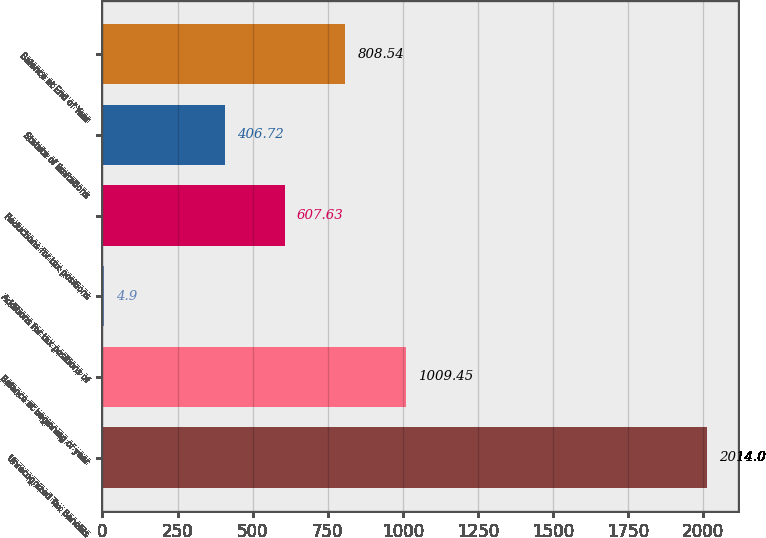Convert chart to OTSL. <chart><loc_0><loc_0><loc_500><loc_500><bar_chart><fcel>Unrecognized Tax Benefits<fcel>Balance at beginning of year<fcel>Additions for tax positions of<fcel>Reductions for tax positions<fcel>Statute of limitations<fcel>Balance at End of Year<nl><fcel>2014<fcel>1009.45<fcel>4.9<fcel>607.63<fcel>406.72<fcel>808.54<nl></chart> 